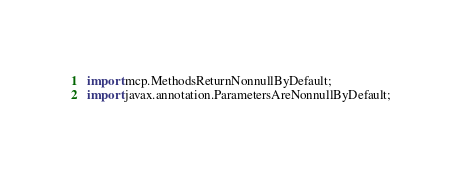<code> <loc_0><loc_0><loc_500><loc_500><_Java_>import mcp.MethodsReturnNonnullByDefault;
import javax.annotation.ParametersAreNonnullByDefault;</code> 